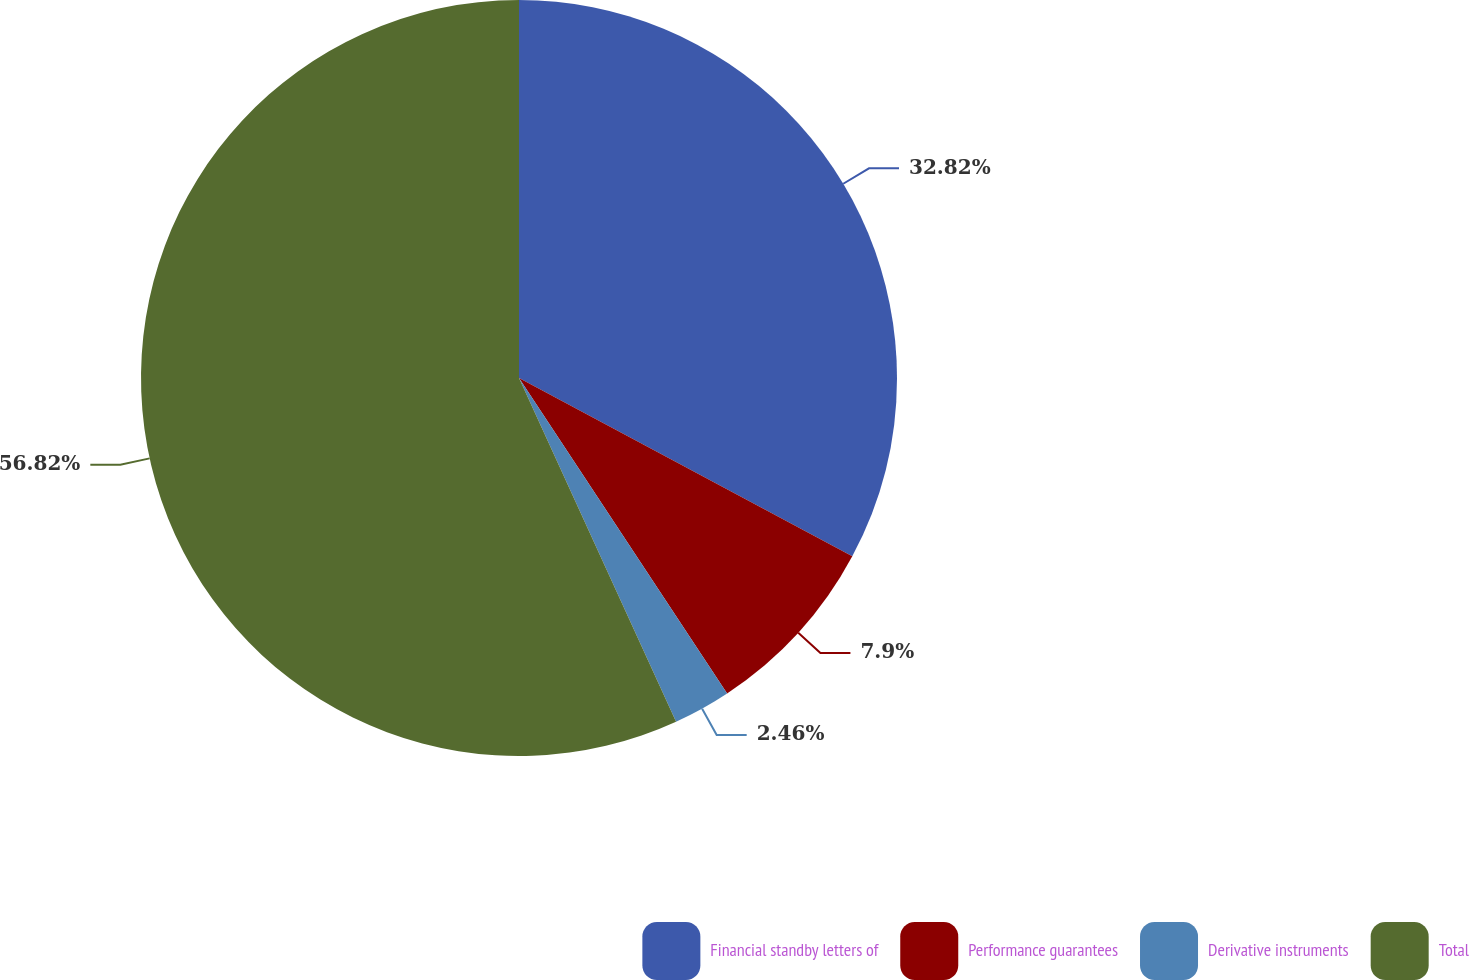Convert chart. <chart><loc_0><loc_0><loc_500><loc_500><pie_chart><fcel>Financial standby letters of<fcel>Performance guarantees<fcel>Derivative instruments<fcel>Total<nl><fcel>32.82%<fcel>7.9%<fcel>2.46%<fcel>56.82%<nl></chart> 